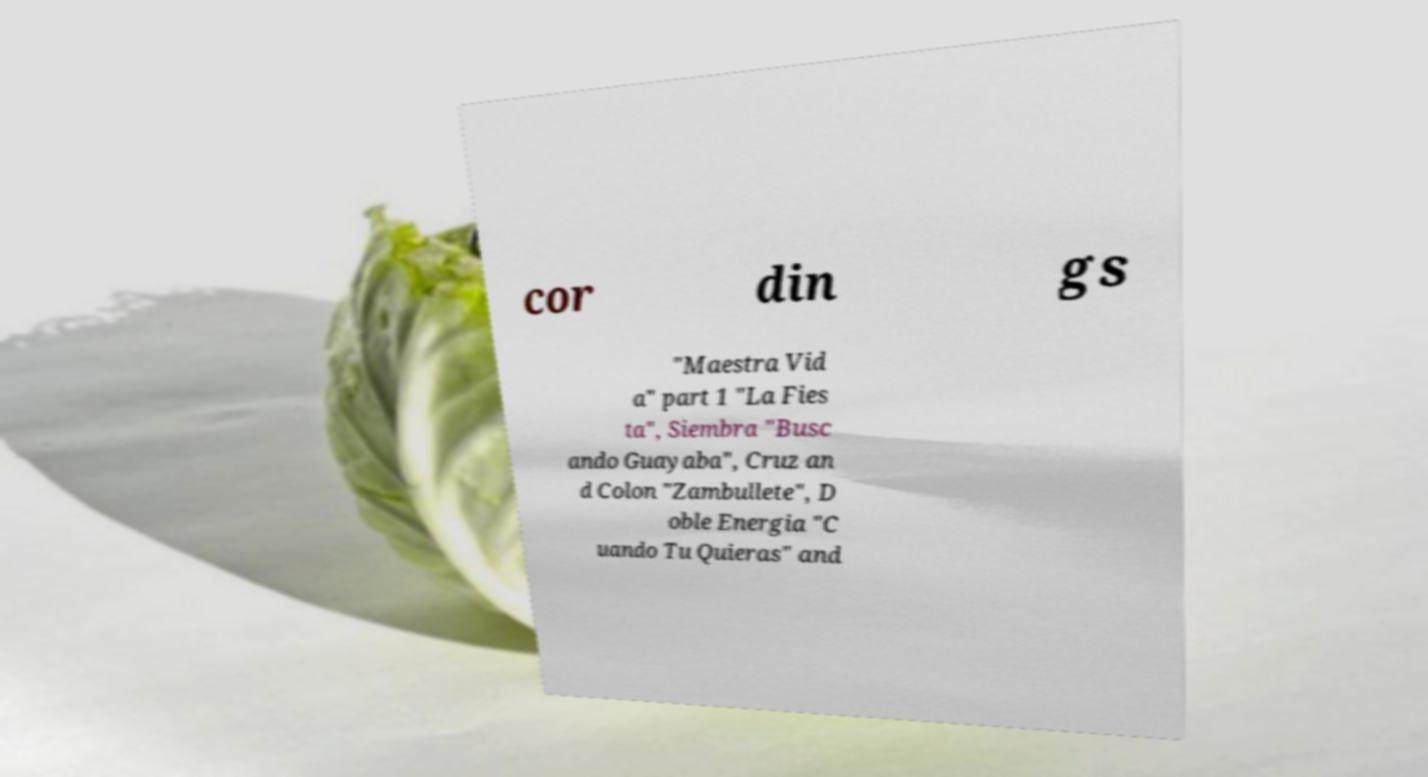Could you extract and type out the text from this image? cor din gs "Maestra Vid a" part 1 "La Fies ta", Siembra "Busc ando Guayaba", Cruz an d Colon "Zambullete", D oble Energia "C uando Tu Quieras" and 